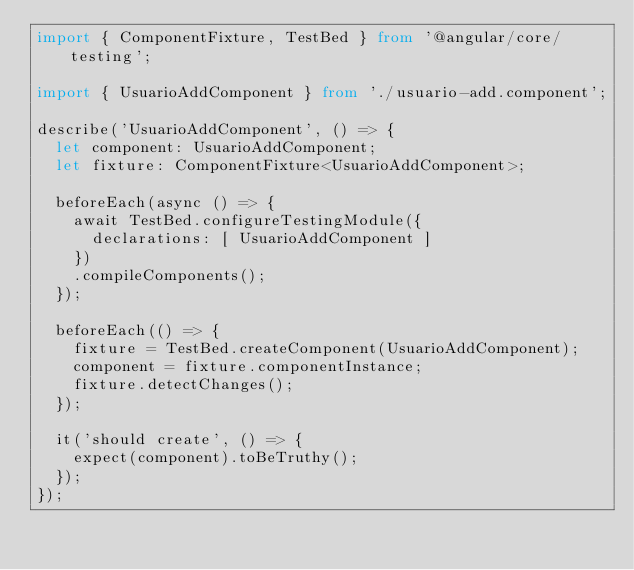Convert code to text. <code><loc_0><loc_0><loc_500><loc_500><_TypeScript_>import { ComponentFixture, TestBed } from '@angular/core/testing';

import { UsuarioAddComponent } from './usuario-add.component';

describe('UsuarioAddComponent', () => {
  let component: UsuarioAddComponent;
  let fixture: ComponentFixture<UsuarioAddComponent>;

  beforeEach(async () => {
    await TestBed.configureTestingModule({
      declarations: [ UsuarioAddComponent ]
    })
    .compileComponents();
  });

  beforeEach(() => {
    fixture = TestBed.createComponent(UsuarioAddComponent);
    component = fixture.componentInstance;
    fixture.detectChanges();
  });

  it('should create', () => {
    expect(component).toBeTruthy();
  });
});
</code> 